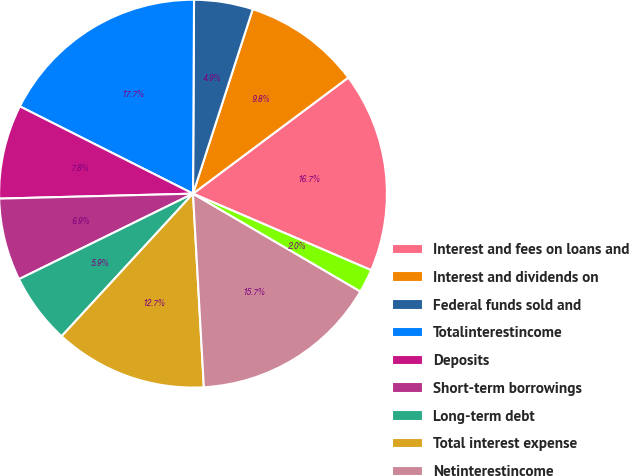<chart> <loc_0><loc_0><loc_500><loc_500><pie_chart><fcel>Interest and fees on loans and<fcel>Interest and dividends on<fcel>Federal funds sold and<fcel>Totalinterestincome<fcel>Deposits<fcel>Short-term borrowings<fcel>Long-term debt<fcel>Total interest expense<fcel>Netinterestincome<fcel>Trading account profits<nl><fcel>16.67%<fcel>9.8%<fcel>4.9%<fcel>17.65%<fcel>7.84%<fcel>6.86%<fcel>5.88%<fcel>12.74%<fcel>15.69%<fcel>1.96%<nl></chart> 